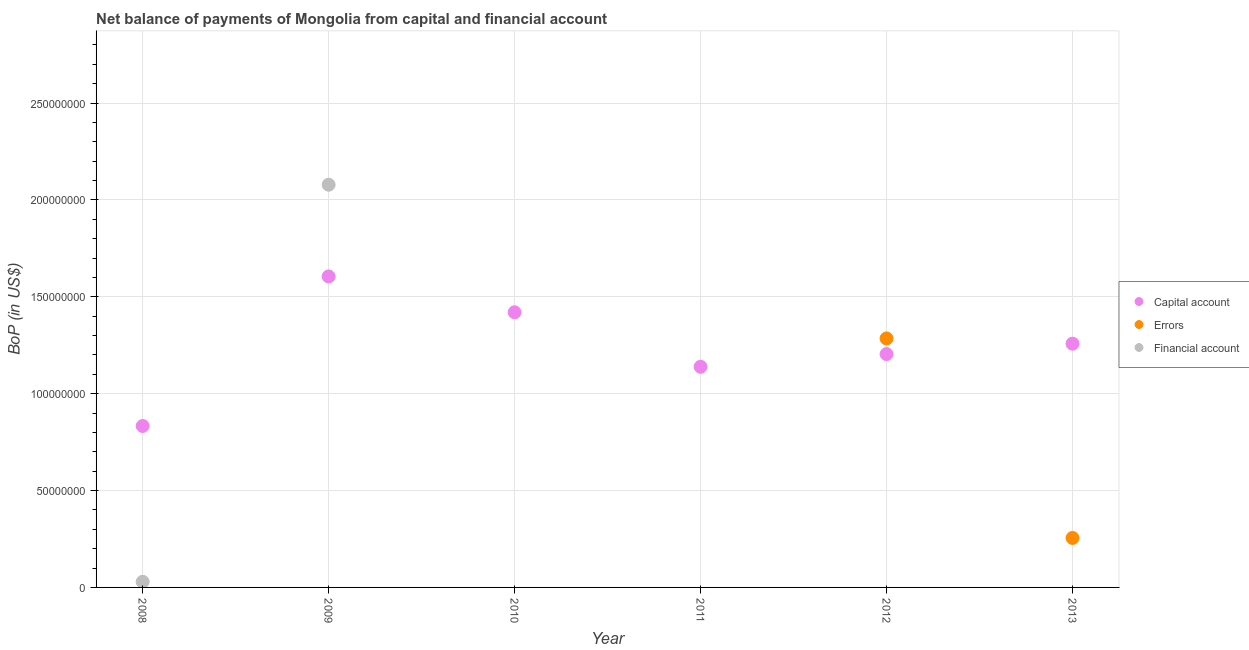Is the number of dotlines equal to the number of legend labels?
Make the answer very short. No. What is the amount of financial account in 2009?
Give a very brief answer. 2.08e+08. Across all years, what is the maximum amount of financial account?
Your response must be concise. 2.08e+08. Across all years, what is the minimum amount of net capital account?
Your answer should be compact. 8.33e+07. What is the total amount of errors in the graph?
Provide a succinct answer. 1.54e+08. What is the difference between the amount of financial account in 2008 and that in 2009?
Provide a succinct answer. -2.05e+08. What is the difference between the amount of financial account in 2010 and the amount of net capital account in 2013?
Your answer should be very brief. -1.26e+08. What is the average amount of financial account per year?
Offer a very short reply. 3.51e+07. In the year 2012, what is the difference between the amount of errors and amount of net capital account?
Provide a succinct answer. 8.08e+06. What is the ratio of the amount of net capital account in 2009 to that in 2012?
Your answer should be very brief. 1.33. What is the difference between the highest and the second highest amount of net capital account?
Keep it short and to the point. 1.85e+07. What is the difference between the highest and the lowest amount of errors?
Your answer should be compact. 1.29e+08. Is it the case that in every year, the sum of the amount of net capital account and amount of errors is greater than the amount of financial account?
Your answer should be compact. No. Is the amount of net capital account strictly greater than the amount of financial account over the years?
Offer a very short reply. No. What is the difference between two consecutive major ticks on the Y-axis?
Offer a very short reply. 5.00e+07. Does the graph contain any zero values?
Offer a very short reply. Yes. How are the legend labels stacked?
Offer a very short reply. Vertical. What is the title of the graph?
Give a very brief answer. Net balance of payments of Mongolia from capital and financial account. What is the label or title of the X-axis?
Your answer should be compact. Year. What is the label or title of the Y-axis?
Offer a very short reply. BoP (in US$). What is the BoP (in US$) of Capital account in 2008?
Offer a terse response. 8.33e+07. What is the BoP (in US$) of Errors in 2008?
Keep it short and to the point. 0. What is the BoP (in US$) in Financial account in 2008?
Keep it short and to the point. 2.91e+06. What is the BoP (in US$) in Capital account in 2009?
Ensure brevity in your answer.  1.60e+08. What is the BoP (in US$) of Errors in 2009?
Offer a terse response. 0. What is the BoP (in US$) in Financial account in 2009?
Provide a succinct answer. 2.08e+08. What is the BoP (in US$) of Capital account in 2010?
Make the answer very short. 1.42e+08. What is the BoP (in US$) of Errors in 2010?
Provide a short and direct response. 0. What is the BoP (in US$) in Financial account in 2010?
Make the answer very short. 0. What is the BoP (in US$) of Capital account in 2011?
Your answer should be very brief. 1.14e+08. What is the BoP (in US$) of Errors in 2011?
Ensure brevity in your answer.  0. What is the BoP (in US$) in Capital account in 2012?
Keep it short and to the point. 1.20e+08. What is the BoP (in US$) in Errors in 2012?
Provide a short and direct response. 1.29e+08. What is the BoP (in US$) in Capital account in 2013?
Provide a short and direct response. 1.26e+08. What is the BoP (in US$) in Errors in 2013?
Your answer should be very brief. 2.55e+07. Across all years, what is the maximum BoP (in US$) in Capital account?
Provide a short and direct response. 1.60e+08. Across all years, what is the maximum BoP (in US$) of Errors?
Your answer should be compact. 1.29e+08. Across all years, what is the maximum BoP (in US$) of Financial account?
Provide a succinct answer. 2.08e+08. Across all years, what is the minimum BoP (in US$) in Capital account?
Keep it short and to the point. 8.33e+07. What is the total BoP (in US$) in Capital account in the graph?
Give a very brief answer. 7.46e+08. What is the total BoP (in US$) of Errors in the graph?
Ensure brevity in your answer.  1.54e+08. What is the total BoP (in US$) of Financial account in the graph?
Make the answer very short. 2.11e+08. What is the difference between the BoP (in US$) in Capital account in 2008 and that in 2009?
Make the answer very short. -7.72e+07. What is the difference between the BoP (in US$) in Financial account in 2008 and that in 2009?
Offer a very short reply. -2.05e+08. What is the difference between the BoP (in US$) of Capital account in 2008 and that in 2010?
Your answer should be very brief. -5.87e+07. What is the difference between the BoP (in US$) in Capital account in 2008 and that in 2011?
Provide a succinct answer. -3.05e+07. What is the difference between the BoP (in US$) of Capital account in 2008 and that in 2012?
Offer a very short reply. -3.71e+07. What is the difference between the BoP (in US$) of Capital account in 2008 and that in 2013?
Your answer should be compact. -4.25e+07. What is the difference between the BoP (in US$) in Capital account in 2009 and that in 2010?
Provide a succinct answer. 1.85e+07. What is the difference between the BoP (in US$) in Capital account in 2009 and that in 2011?
Provide a short and direct response. 4.66e+07. What is the difference between the BoP (in US$) in Capital account in 2009 and that in 2012?
Your answer should be compact. 4.01e+07. What is the difference between the BoP (in US$) in Capital account in 2009 and that in 2013?
Your answer should be very brief. 3.47e+07. What is the difference between the BoP (in US$) of Capital account in 2010 and that in 2011?
Provide a succinct answer. 2.81e+07. What is the difference between the BoP (in US$) in Capital account in 2010 and that in 2012?
Make the answer very short. 2.16e+07. What is the difference between the BoP (in US$) in Capital account in 2010 and that in 2013?
Your answer should be very brief. 1.62e+07. What is the difference between the BoP (in US$) of Capital account in 2011 and that in 2012?
Make the answer very short. -6.56e+06. What is the difference between the BoP (in US$) in Capital account in 2011 and that in 2013?
Your answer should be very brief. -1.19e+07. What is the difference between the BoP (in US$) of Capital account in 2012 and that in 2013?
Ensure brevity in your answer.  -5.36e+06. What is the difference between the BoP (in US$) in Errors in 2012 and that in 2013?
Your response must be concise. 1.03e+08. What is the difference between the BoP (in US$) of Capital account in 2008 and the BoP (in US$) of Financial account in 2009?
Provide a succinct answer. -1.25e+08. What is the difference between the BoP (in US$) in Capital account in 2008 and the BoP (in US$) in Errors in 2012?
Keep it short and to the point. -4.52e+07. What is the difference between the BoP (in US$) of Capital account in 2008 and the BoP (in US$) of Errors in 2013?
Your response must be concise. 5.78e+07. What is the difference between the BoP (in US$) of Capital account in 2009 and the BoP (in US$) of Errors in 2012?
Your response must be concise. 3.20e+07. What is the difference between the BoP (in US$) of Capital account in 2009 and the BoP (in US$) of Errors in 2013?
Your answer should be very brief. 1.35e+08. What is the difference between the BoP (in US$) of Capital account in 2010 and the BoP (in US$) of Errors in 2012?
Provide a short and direct response. 1.35e+07. What is the difference between the BoP (in US$) in Capital account in 2010 and the BoP (in US$) in Errors in 2013?
Keep it short and to the point. 1.16e+08. What is the difference between the BoP (in US$) in Capital account in 2011 and the BoP (in US$) in Errors in 2012?
Your response must be concise. -1.46e+07. What is the difference between the BoP (in US$) in Capital account in 2011 and the BoP (in US$) in Errors in 2013?
Provide a short and direct response. 8.83e+07. What is the difference between the BoP (in US$) in Capital account in 2012 and the BoP (in US$) in Errors in 2013?
Make the answer very short. 9.49e+07. What is the average BoP (in US$) of Capital account per year?
Offer a terse response. 1.24e+08. What is the average BoP (in US$) in Errors per year?
Offer a terse response. 2.57e+07. What is the average BoP (in US$) in Financial account per year?
Ensure brevity in your answer.  3.51e+07. In the year 2008, what is the difference between the BoP (in US$) of Capital account and BoP (in US$) of Financial account?
Make the answer very short. 8.04e+07. In the year 2009, what is the difference between the BoP (in US$) of Capital account and BoP (in US$) of Financial account?
Ensure brevity in your answer.  -4.73e+07. In the year 2012, what is the difference between the BoP (in US$) of Capital account and BoP (in US$) of Errors?
Your answer should be very brief. -8.08e+06. In the year 2013, what is the difference between the BoP (in US$) in Capital account and BoP (in US$) in Errors?
Give a very brief answer. 1.00e+08. What is the ratio of the BoP (in US$) of Capital account in 2008 to that in 2009?
Your answer should be compact. 0.52. What is the ratio of the BoP (in US$) of Financial account in 2008 to that in 2009?
Your response must be concise. 0.01. What is the ratio of the BoP (in US$) of Capital account in 2008 to that in 2010?
Your response must be concise. 0.59. What is the ratio of the BoP (in US$) in Capital account in 2008 to that in 2011?
Make the answer very short. 0.73. What is the ratio of the BoP (in US$) of Capital account in 2008 to that in 2012?
Your response must be concise. 0.69. What is the ratio of the BoP (in US$) in Capital account in 2008 to that in 2013?
Offer a very short reply. 0.66. What is the ratio of the BoP (in US$) of Capital account in 2009 to that in 2010?
Make the answer very short. 1.13. What is the ratio of the BoP (in US$) of Capital account in 2009 to that in 2011?
Ensure brevity in your answer.  1.41. What is the ratio of the BoP (in US$) of Capital account in 2009 to that in 2012?
Give a very brief answer. 1.33. What is the ratio of the BoP (in US$) of Capital account in 2009 to that in 2013?
Your answer should be compact. 1.28. What is the ratio of the BoP (in US$) of Capital account in 2010 to that in 2011?
Ensure brevity in your answer.  1.25. What is the ratio of the BoP (in US$) in Capital account in 2010 to that in 2012?
Make the answer very short. 1.18. What is the ratio of the BoP (in US$) in Capital account in 2010 to that in 2013?
Keep it short and to the point. 1.13. What is the ratio of the BoP (in US$) in Capital account in 2011 to that in 2012?
Keep it short and to the point. 0.95. What is the ratio of the BoP (in US$) of Capital account in 2011 to that in 2013?
Give a very brief answer. 0.91. What is the ratio of the BoP (in US$) of Capital account in 2012 to that in 2013?
Ensure brevity in your answer.  0.96. What is the ratio of the BoP (in US$) of Errors in 2012 to that in 2013?
Your answer should be very brief. 5.03. What is the difference between the highest and the second highest BoP (in US$) of Capital account?
Give a very brief answer. 1.85e+07. What is the difference between the highest and the lowest BoP (in US$) of Capital account?
Provide a succinct answer. 7.72e+07. What is the difference between the highest and the lowest BoP (in US$) of Errors?
Your answer should be very brief. 1.29e+08. What is the difference between the highest and the lowest BoP (in US$) of Financial account?
Provide a short and direct response. 2.08e+08. 